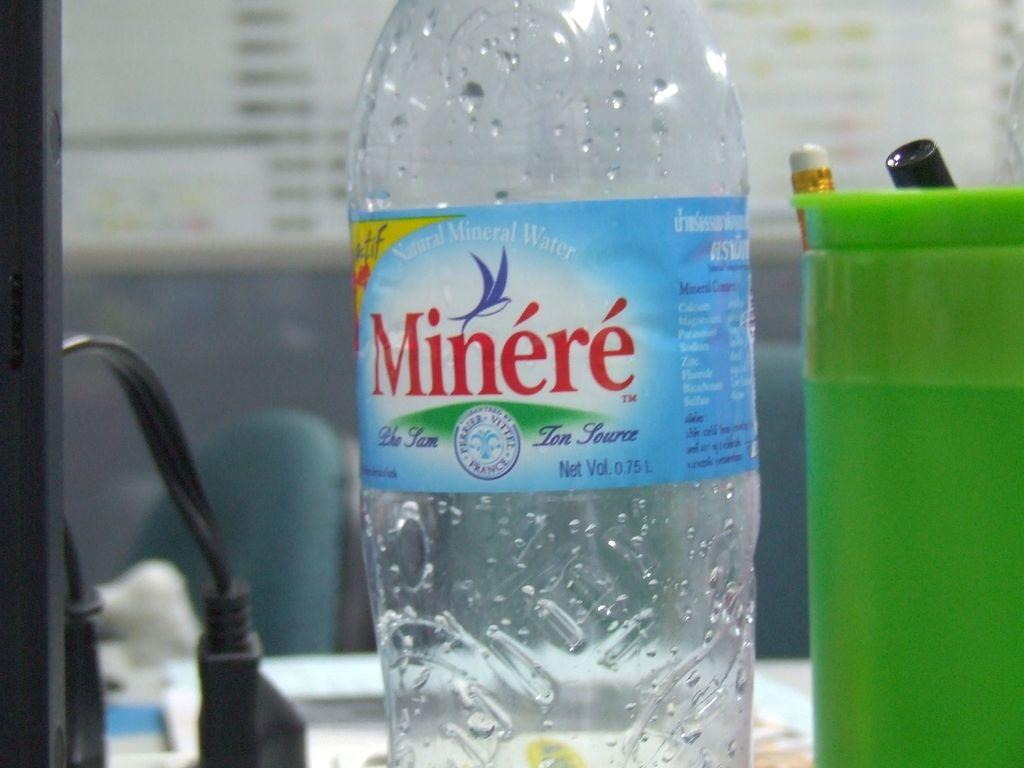<image>
Write a terse but informative summary of the picture. an empty water bottle with the Minere brand on it. 